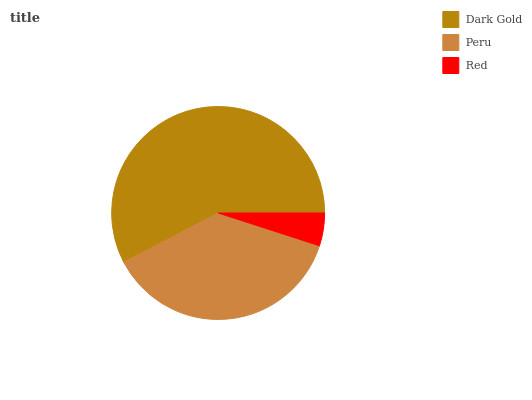Is Red the minimum?
Answer yes or no. Yes. Is Dark Gold the maximum?
Answer yes or no. Yes. Is Peru the minimum?
Answer yes or no. No. Is Peru the maximum?
Answer yes or no. No. Is Dark Gold greater than Peru?
Answer yes or no. Yes. Is Peru less than Dark Gold?
Answer yes or no. Yes. Is Peru greater than Dark Gold?
Answer yes or no. No. Is Dark Gold less than Peru?
Answer yes or no. No. Is Peru the high median?
Answer yes or no. Yes. Is Peru the low median?
Answer yes or no. Yes. Is Dark Gold the high median?
Answer yes or no. No. Is Red the low median?
Answer yes or no. No. 